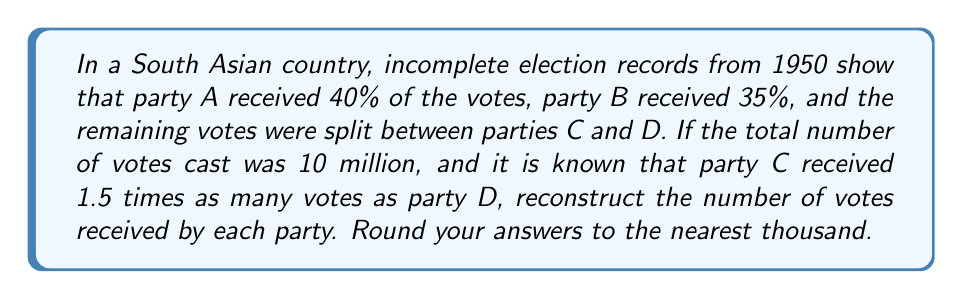Teach me how to tackle this problem. Let's approach this step-by-step:

1) First, let's define our variables:
   Let $x$ be the number of votes for party C
   Let $y$ be the number of votes for party D

2) We know that the total number of votes is 10 million:
   $$10,000,000 = 0.40 \cdot 10,000,000 + 0.35 \cdot 10,000,000 + x + y$$

3) Simplify:
   $$10,000,000 = 4,000,000 + 3,500,000 + x + y$$
   $$2,500,000 = x + y$$

4) We also know that party C received 1.5 times as many votes as party D:
   $$x = 1.5y$$

5) Substitute this into our equation from step 3:
   $$2,500,000 = 1.5y + y = 2.5y$$

6) Solve for $y$:
   $$y = 2,500,000 / 2.5 = 1,000,000$$

7) Now we can find $x$:
   $$x = 1.5y = 1.5 \cdot 1,000,000 = 1,500,000$$

8) Let's verify our results:
   Party A: $0.40 \cdot 10,000,000 = 4,000,000$
   Party B: $0.35 \cdot 10,000,000 = 3,500,000$
   Party C: $1,500,000$
   Party D: $1,000,000$
   Total: $4,000,000 + 3,500,000 + 1,500,000 + 1,000,000 = 10,000,000$

9) Rounding to the nearest thousand:
   Party A: 4,000,000
   Party B: 3,500,000
   Party C: 1,500,000
   Party D: 1,000,000
Answer: Party A: 4,000,000; Party B: 3,500,000; Party C: 1,500,000; Party D: 1,000,000 